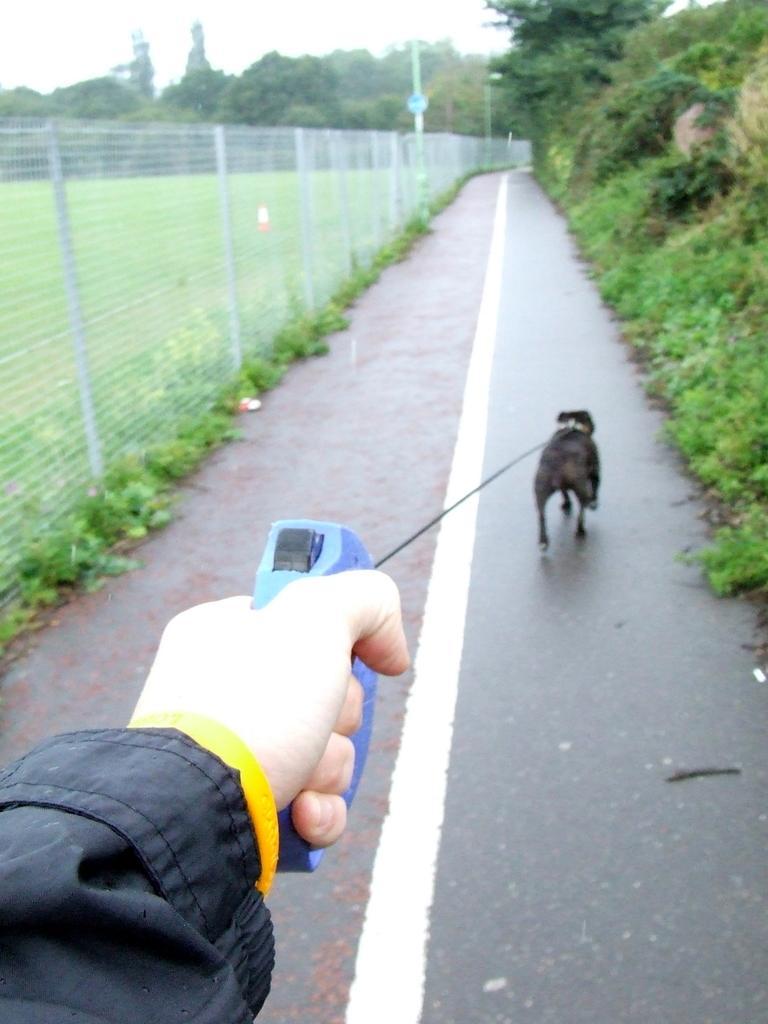Could you give a brief overview of what you see in this image? In this picture I can see a person holding the belt of a dog, which is on the road, and there is grass, plants, wire fence, poles, trees, and in the background there is sky. 